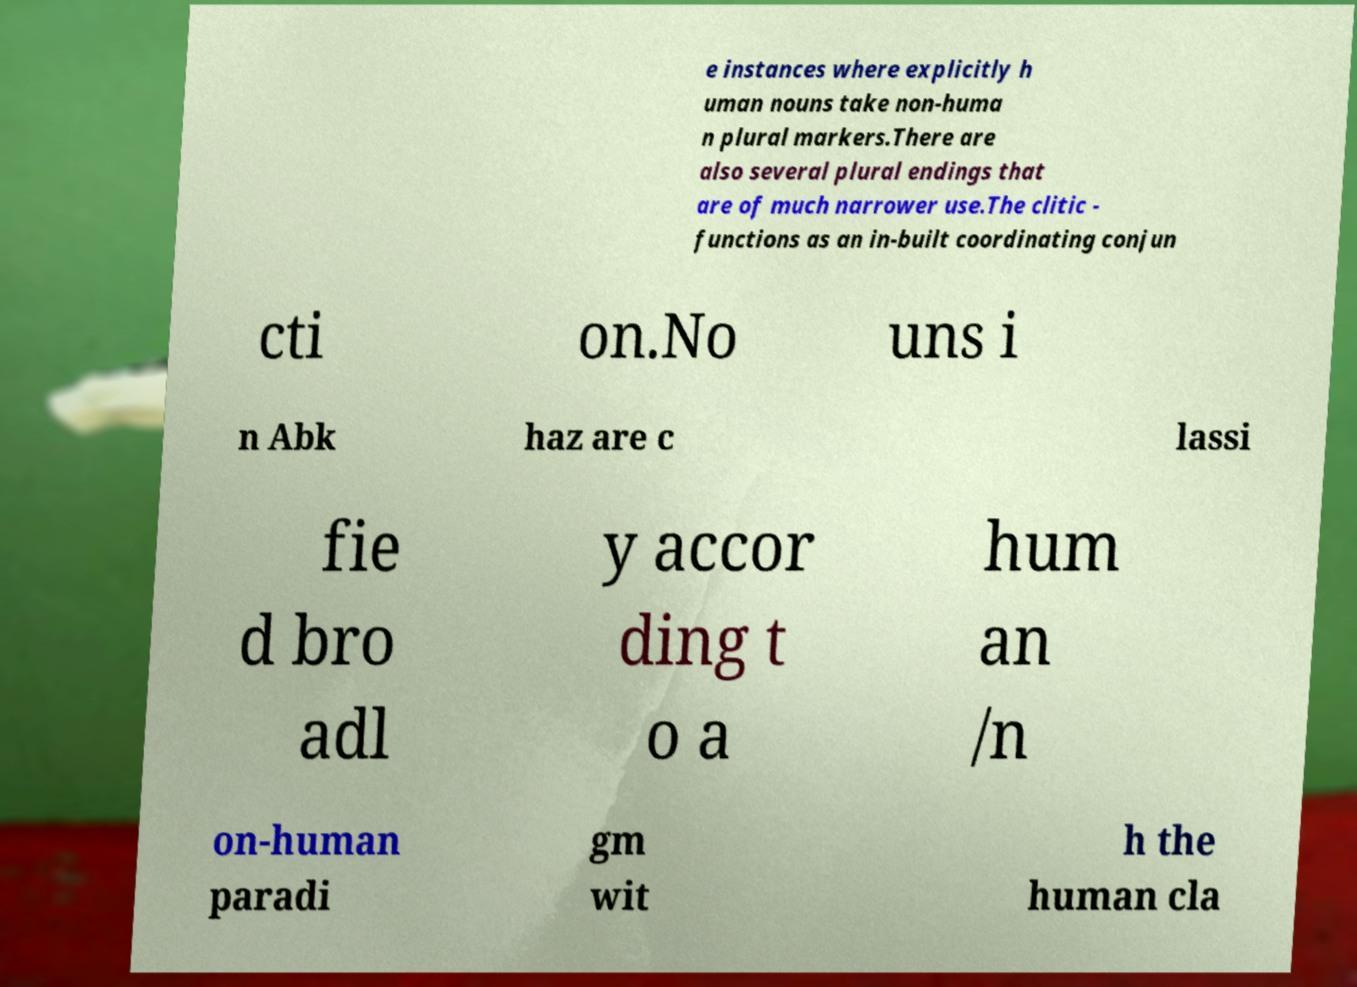Could you assist in decoding the text presented in this image and type it out clearly? e instances where explicitly h uman nouns take non-huma n plural markers.There are also several plural endings that are of much narrower use.The clitic - functions as an in-built coordinating conjun cti on.No uns i n Abk haz are c lassi fie d bro adl y accor ding t o a hum an /n on-human paradi gm wit h the human cla 